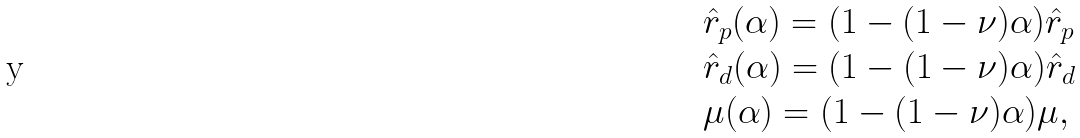<formula> <loc_0><loc_0><loc_500><loc_500>& \hat { r } _ { p } ( \alpha ) = ( 1 - ( 1 - \nu ) \alpha ) \hat { r } _ { p } \\ & \hat { r } _ { d } ( \alpha ) = ( 1 - ( 1 - \nu ) \alpha ) \hat { r } _ { d } \\ & \mu ( \alpha ) = ( 1 - ( 1 - \nu ) \alpha ) \mu ,</formula> 